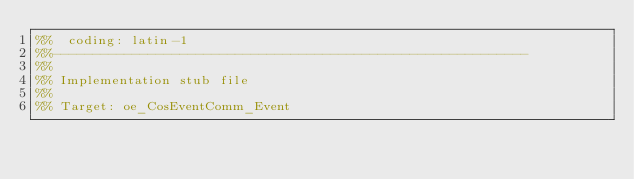Convert code to text. <code><loc_0><loc_0><loc_500><loc_500><_Erlang_>%%  coding: latin-1
%%------------------------------------------------------------
%%
%% Implementation stub file
%% 
%% Target: oe_CosEventComm_Event</code> 